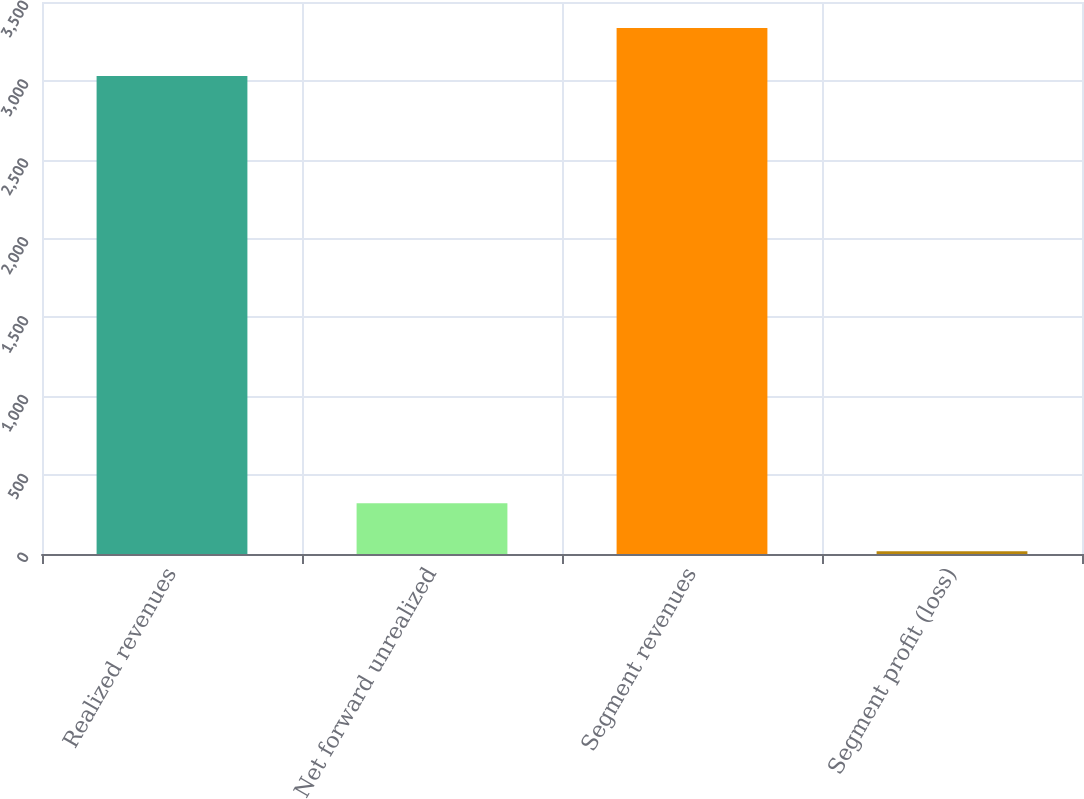<chart> <loc_0><loc_0><loc_500><loc_500><bar_chart><fcel>Realized revenues<fcel>Net forward unrealized<fcel>Segment revenues<fcel>Segment profit (loss)<nl><fcel>3031<fcel>321.4<fcel>3334.4<fcel>18<nl></chart> 